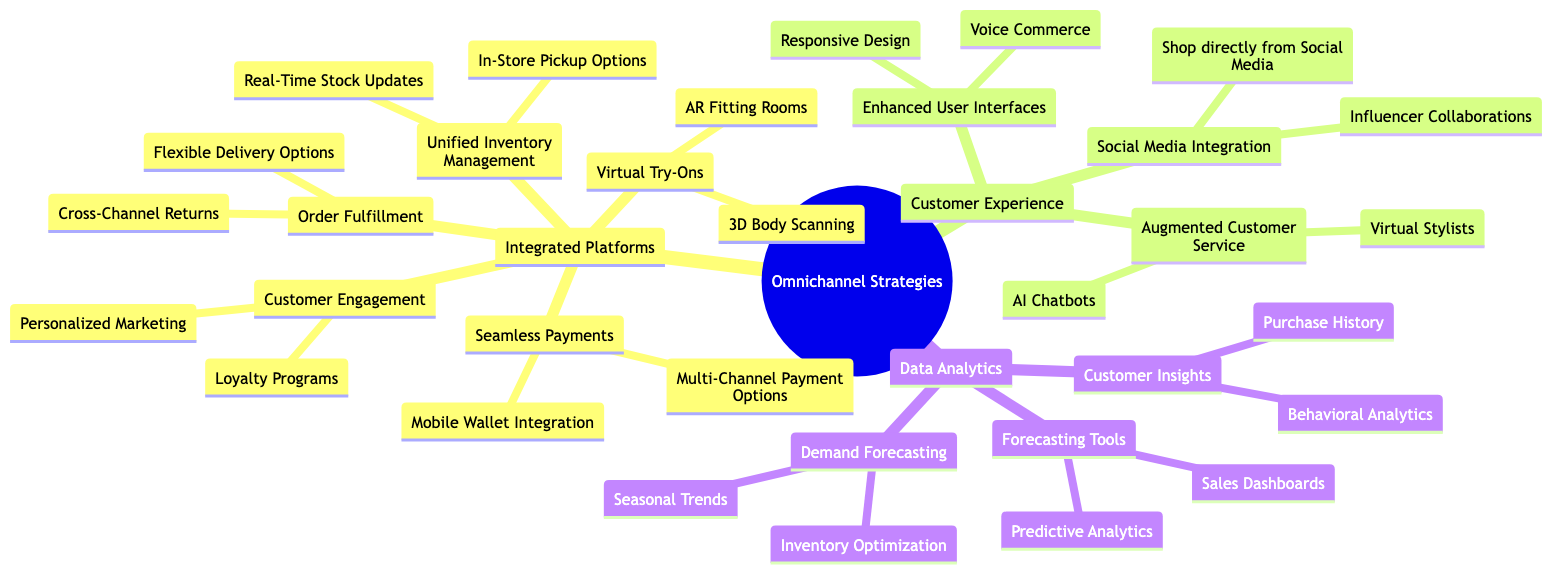What are the two components under Integrated Platforms? Integrated Platforms has two main components: Virtual Try-Ons and Unified Inventory Management. These can be identified as the first two child nodes under the Integrated Platforms node in the diagram.
Answer: Virtual Try-Ons, Unified Inventory Management How many categories are there under the main node Omnichannel Strategies? The main node Omnichannel Strategies branches into three categories: Integrated Platforms, Customer Experience, and Data Analytics. This counts to a total of three distinct categories present in the diagram.
Answer: 3 What is one method included in Customer Engagement? Under Customer Engagement, one method listed is Personalized Marketing. This can be found as one of the child nodes under the Customer Engagement category in the diagram.
Answer: Personalized Marketing What is the relationship between Augmented Customer Service and AI Chatbots? Augmented Customer Service encompasses AI Chatbots as one of its specific elements, meaning AI Chatbots is a subcategory under Augmented Customer Service, making it directly related.
Answer: Subcategory What can be accessed through Seamless Payments? Seamless Payments includes the component Mobile Wallet Integration, which allows customers to make quick and secure payments in-store, displaying practical examples of payment methods.
Answer: Mobile Wallet Integration How many tools are listed under Demand Forecasting? There are two tools listed under Demand Forecasting: Seasonal Trends and Inventory Optimization which can be identified as sub-nodes stemming from the Demand Forecasting category.
Answer: 2 What type of analytics is used for Predictive Analytics? Predictive Analytics utilizes machine learning algorithms, as specified under the Forecasting Tools category which describes how this type of analysis works in forecasting.
Answer: Machine learning algorithms What does Integrated Platforms offer for customer convenience? Integrated Platforms offers In-Store Pickup Options, which facilitates customer convenience by allowing them to pick up purchases made online in physical stores, as indicated in the diagram.
Answer: In-Store Pickup Options What enhances the online shopping experience mentioned in Enhanced User Interfaces? Responsive Design enhances the online shopping experience as it enables interfaces to adapt to various devices, which improves usability and customer satisfaction.
Answer: Responsive Design 